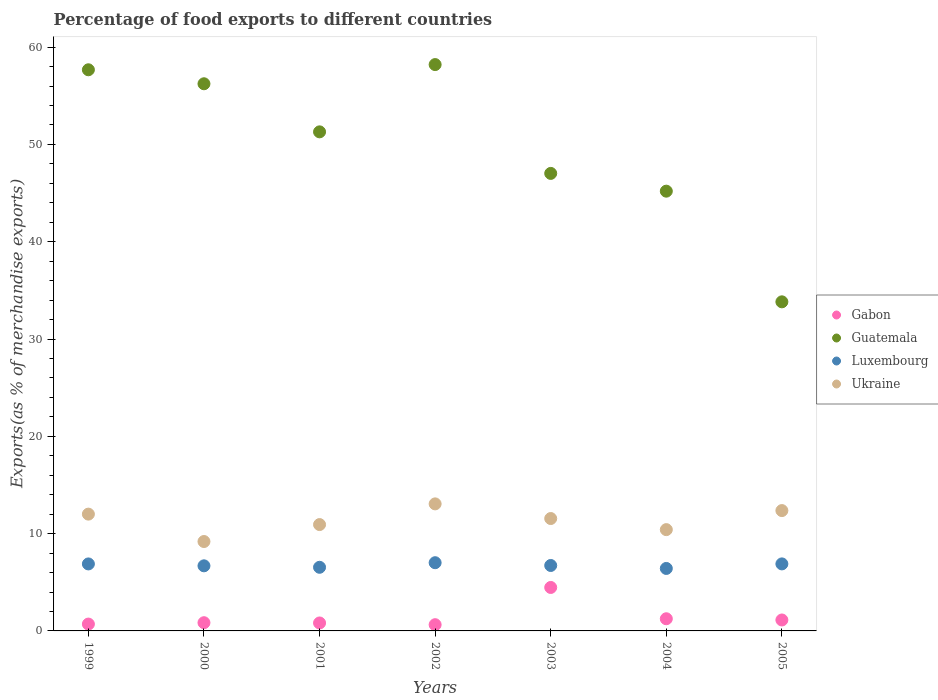How many different coloured dotlines are there?
Ensure brevity in your answer.  4. What is the percentage of exports to different countries in Ukraine in 2005?
Make the answer very short. 12.37. Across all years, what is the maximum percentage of exports to different countries in Luxembourg?
Provide a succinct answer. 7.01. Across all years, what is the minimum percentage of exports to different countries in Ukraine?
Provide a succinct answer. 9.19. What is the total percentage of exports to different countries in Guatemala in the graph?
Provide a succinct answer. 349.43. What is the difference between the percentage of exports to different countries in Guatemala in 1999 and that in 2004?
Ensure brevity in your answer.  12.48. What is the difference between the percentage of exports to different countries in Luxembourg in 2000 and the percentage of exports to different countries in Ukraine in 2001?
Your answer should be very brief. -4.24. What is the average percentage of exports to different countries in Gabon per year?
Your response must be concise. 1.41. In the year 2003, what is the difference between the percentage of exports to different countries in Gabon and percentage of exports to different countries in Luxembourg?
Make the answer very short. -2.26. In how many years, is the percentage of exports to different countries in Luxembourg greater than 4 %?
Your response must be concise. 7. What is the ratio of the percentage of exports to different countries in Ukraine in 1999 to that in 2005?
Your response must be concise. 0.97. Is the percentage of exports to different countries in Guatemala in 2004 less than that in 2005?
Offer a terse response. No. Is the difference between the percentage of exports to different countries in Gabon in 2000 and 2004 greater than the difference between the percentage of exports to different countries in Luxembourg in 2000 and 2004?
Give a very brief answer. No. What is the difference between the highest and the second highest percentage of exports to different countries in Gabon?
Provide a short and direct response. 3.22. What is the difference between the highest and the lowest percentage of exports to different countries in Luxembourg?
Keep it short and to the point. 0.59. Is it the case that in every year, the sum of the percentage of exports to different countries in Gabon and percentage of exports to different countries in Guatemala  is greater than the sum of percentage of exports to different countries in Ukraine and percentage of exports to different countries in Luxembourg?
Your answer should be very brief. Yes. Is the percentage of exports to different countries in Gabon strictly greater than the percentage of exports to different countries in Guatemala over the years?
Your answer should be very brief. No. What is the difference between two consecutive major ticks on the Y-axis?
Your answer should be very brief. 10. Are the values on the major ticks of Y-axis written in scientific E-notation?
Offer a terse response. No. Does the graph contain any zero values?
Keep it short and to the point. No. Where does the legend appear in the graph?
Offer a terse response. Center right. How many legend labels are there?
Offer a terse response. 4. What is the title of the graph?
Offer a terse response. Percentage of food exports to different countries. Does "Korea (Republic)" appear as one of the legend labels in the graph?
Offer a very short reply. No. What is the label or title of the X-axis?
Your answer should be very brief. Years. What is the label or title of the Y-axis?
Your answer should be very brief. Exports(as % of merchandise exports). What is the Exports(as % of merchandise exports) of Gabon in 1999?
Offer a terse response. 0.7. What is the Exports(as % of merchandise exports) in Guatemala in 1999?
Give a very brief answer. 57.67. What is the Exports(as % of merchandise exports) in Luxembourg in 1999?
Ensure brevity in your answer.  6.88. What is the Exports(as % of merchandise exports) of Ukraine in 1999?
Give a very brief answer. 12. What is the Exports(as % of merchandise exports) of Gabon in 2000?
Keep it short and to the point. 0.84. What is the Exports(as % of merchandise exports) of Guatemala in 2000?
Your answer should be very brief. 56.23. What is the Exports(as % of merchandise exports) in Luxembourg in 2000?
Your answer should be compact. 6.69. What is the Exports(as % of merchandise exports) of Ukraine in 2000?
Offer a terse response. 9.19. What is the Exports(as % of merchandise exports) of Gabon in 2001?
Your answer should be compact. 0.82. What is the Exports(as % of merchandise exports) in Guatemala in 2001?
Your response must be concise. 51.29. What is the Exports(as % of merchandise exports) of Luxembourg in 2001?
Provide a short and direct response. 6.54. What is the Exports(as % of merchandise exports) of Ukraine in 2001?
Make the answer very short. 10.93. What is the Exports(as % of merchandise exports) in Gabon in 2002?
Make the answer very short. 0.64. What is the Exports(as % of merchandise exports) in Guatemala in 2002?
Your answer should be very brief. 58.2. What is the Exports(as % of merchandise exports) in Luxembourg in 2002?
Offer a terse response. 7.01. What is the Exports(as % of merchandise exports) in Ukraine in 2002?
Your answer should be compact. 13.06. What is the Exports(as % of merchandise exports) in Gabon in 2003?
Give a very brief answer. 4.47. What is the Exports(as % of merchandise exports) of Guatemala in 2003?
Keep it short and to the point. 47.02. What is the Exports(as % of merchandise exports) in Luxembourg in 2003?
Provide a succinct answer. 6.72. What is the Exports(as % of merchandise exports) in Ukraine in 2003?
Your answer should be very brief. 11.55. What is the Exports(as % of merchandise exports) of Gabon in 2004?
Offer a very short reply. 1.25. What is the Exports(as % of merchandise exports) in Guatemala in 2004?
Ensure brevity in your answer.  45.19. What is the Exports(as % of merchandise exports) in Luxembourg in 2004?
Offer a terse response. 6.42. What is the Exports(as % of merchandise exports) of Ukraine in 2004?
Your response must be concise. 10.41. What is the Exports(as % of merchandise exports) of Gabon in 2005?
Provide a short and direct response. 1.12. What is the Exports(as % of merchandise exports) of Guatemala in 2005?
Give a very brief answer. 33.82. What is the Exports(as % of merchandise exports) of Luxembourg in 2005?
Give a very brief answer. 6.89. What is the Exports(as % of merchandise exports) in Ukraine in 2005?
Provide a short and direct response. 12.37. Across all years, what is the maximum Exports(as % of merchandise exports) of Gabon?
Your answer should be compact. 4.47. Across all years, what is the maximum Exports(as % of merchandise exports) of Guatemala?
Offer a very short reply. 58.2. Across all years, what is the maximum Exports(as % of merchandise exports) of Luxembourg?
Offer a terse response. 7.01. Across all years, what is the maximum Exports(as % of merchandise exports) in Ukraine?
Give a very brief answer. 13.06. Across all years, what is the minimum Exports(as % of merchandise exports) of Gabon?
Make the answer very short. 0.64. Across all years, what is the minimum Exports(as % of merchandise exports) of Guatemala?
Your response must be concise. 33.82. Across all years, what is the minimum Exports(as % of merchandise exports) in Luxembourg?
Keep it short and to the point. 6.42. Across all years, what is the minimum Exports(as % of merchandise exports) in Ukraine?
Make the answer very short. 9.19. What is the total Exports(as % of merchandise exports) of Gabon in the graph?
Your response must be concise. 9.85. What is the total Exports(as % of merchandise exports) in Guatemala in the graph?
Your response must be concise. 349.43. What is the total Exports(as % of merchandise exports) in Luxembourg in the graph?
Provide a succinct answer. 47.16. What is the total Exports(as % of merchandise exports) of Ukraine in the graph?
Provide a short and direct response. 79.5. What is the difference between the Exports(as % of merchandise exports) in Gabon in 1999 and that in 2000?
Give a very brief answer. -0.14. What is the difference between the Exports(as % of merchandise exports) of Guatemala in 1999 and that in 2000?
Give a very brief answer. 1.44. What is the difference between the Exports(as % of merchandise exports) of Luxembourg in 1999 and that in 2000?
Your response must be concise. 0.2. What is the difference between the Exports(as % of merchandise exports) in Ukraine in 1999 and that in 2000?
Offer a very short reply. 2.82. What is the difference between the Exports(as % of merchandise exports) in Gabon in 1999 and that in 2001?
Your answer should be compact. -0.11. What is the difference between the Exports(as % of merchandise exports) in Guatemala in 1999 and that in 2001?
Ensure brevity in your answer.  6.38. What is the difference between the Exports(as % of merchandise exports) in Luxembourg in 1999 and that in 2001?
Keep it short and to the point. 0.35. What is the difference between the Exports(as % of merchandise exports) of Ukraine in 1999 and that in 2001?
Your response must be concise. 1.07. What is the difference between the Exports(as % of merchandise exports) of Gabon in 1999 and that in 2002?
Make the answer very short. 0.06. What is the difference between the Exports(as % of merchandise exports) in Guatemala in 1999 and that in 2002?
Your response must be concise. -0.53. What is the difference between the Exports(as % of merchandise exports) of Luxembourg in 1999 and that in 2002?
Your response must be concise. -0.12. What is the difference between the Exports(as % of merchandise exports) of Ukraine in 1999 and that in 2002?
Your answer should be very brief. -1.05. What is the difference between the Exports(as % of merchandise exports) in Gabon in 1999 and that in 2003?
Provide a succinct answer. -3.76. What is the difference between the Exports(as % of merchandise exports) of Guatemala in 1999 and that in 2003?
Provide a short and direct response. 10.65. What is the difference between the Exports(as % of merchandise exports) in Luxembourg in 1999 and that in 2003?
Ensure brevity in your answer.  0.16. What is the difference between the Exports(as % of merchandise exports) in Ukraine in 1999 and that in 2003?
Your response must be concise. 0.45. What is the difference between the Exports(as % of merchandise exports) in Gabon in 1999 and that in 2004?
Your response must be concise. -0.55. What is the difference between the Exports(as % of merchandise exports) of Guatemala in 1999 and that in 2004?
Your response must be concise. 12.48. What is the difference between the Exports(as % of merchandise exports) of Luxembourg in 1999 and that in 2004?
Give a very brief answer. 0.46. What is the difference between the Exports(as % of merchandise exports) in Ukraine in 1999 and that in 2004?
Make the answer very short. 1.59. What is the difference between the Exports(as % of merchandise exports) of Gabon in 1999 and that in 2005?
Offer a very short reply. -0.42. What is the difference between the Exports(as % of merchandise exports) in Guatemala in 1999 and that in 2005?
Make the answer very short. 23.85. What is the difference between the Exports(as % of merchandise exports) of Luxembourg in 1999 and that in 2005?
Provide a succinct answer. -0. What is the difference between the Exports(as % of merchandise exports) of Ukraine in 1999 and that in 2005?
Your answer should be compact. -0.36. What is the difference between the Exports(as % of merchandise exports) of Gabon in 2000 and that in 2001?
Provide a short and direct response. 0.03. What is the difference between the Exports(as % of merchandise exports) in Guatemala in 2000 and that in 2001?
Make the answer very short. 4.94. What is the difference between the Exports(as % of merchandise exports) in Ukraine in 2000 and that in 2001?
Make the answer very short. -1.74. What is the difference between the Exports(as % of merchandise exports) in Gabon in 2000 and that in 2002?
Provide a succinct answer. 0.2. What is the difference between the Exports(as % of merchandise exports) of Guatemala in 2000 and that in 2002?
Ensure brevity in your answer.  -1.97. What is the difference between the Exports(as % of merchandise exports) of Luxembourg in 2000 and that in 2002?
Give a very brief answer. -0.32. What is the difference between the Exports(as % of merchandise exports) of Ukraine in 2000 and that in 2002?
Give a very brief answer. -3.87. What is the difference between the Exports(as % of merchandise exports) of Gabon in 2000 and that in 2003?
Keep it short and to the point. -3.62. What is the difference between the Exports(as % of merchandise exports) of Guatemala in 2000 and that in 2003?
Your answer should be very brief. 9.21. What is the difference between the Exports(as % of merchandise exports) of Luxembourg in 2000 and that in 2003?
Keep it short and to the point. -0.04. What is the difference between the Exports(as % of merchandise exports) of Ukraine in 2000 and that in 2003?
Your response must be concise. -2.36. What is the difference between the Exports(as % of merchandise exports) in Gabon in 2000 and that in 2004?
Your answer should be very brief. -0.41. What is the difference between the Exports(as % of merchandise exports) in Guatemala in 2000 and that in 2004?
Ensure brevity in your answer.  11.04. What is the difference between the Exports(as % of merchandise exports) of Luxembourg in 2000 and that in 2004?
Give a very brief answer. 0.27. What is the difference between the Exports(as % of merchandise exports) in Ukraine in 2000 and that in 2004?
Your response must be concise. -1.22. What is the difference between the Exports(as % of merchandise exports) in Gabon in 2000 and that in 2005?
Offer a very short reply. -0.28. What is the difference between the Exports(as % of merchandise exports) of Guatemala in 2000 and that in 2005?
Give a very brief answer. 22.41. What is the difference between the Exports(as % of merchandise exports) in Luxembourg in 2000 and that in 2005?
Your answer should be compact. -0.2. What is the difference between the Exports(as % of merchandise exports) in Ukraine in 2000 and that in 2005?
Your answer should be very brief. -3.18. What is the difference between the Exports(as % of merchandise exports) in Gabon in 2001 and that in 2002?
Your response must be concise. 0.18. What is the difference between the Exports(as % of merchandise exports) of Guatemala in 2001 and that in 2002?
Provide a short and direct response. -6.91. What is the difference between the Exports(as % of merchandise exports) of Luxembourg in 2001 and that in 2002?
Provide a short and direct response. -0.47. What is the difference between the Exports(as % of merchandise exports) of Ukraine in 2001 and that in 2002?
Ensure brevity in your answer.  -2.13. What is the difference between the Exports(as % of merchandise exports) of Gabon in 2001 and that in 2003?
Provide a short and direct response. -3.65. What is the difference between the Exports(as % of merchandise exports) of Guatemala in 2001 and that in 2003?
Offer a terse response. 4.27. What is the difference between the Exports(as % of merchandise exports) in Luxembourg in 2001 and that in 2003?
Offer a very short reply. -0.19. What is the difference between the Exports(as % of merchandise exports) in Ukraine in 2001 and that in 2003?
Provide a succinct answer. -0.62. What is the difference between the Exports(as % of merchandise exports) of Gabon in 2001 and that in 2004?
Your answer should be compact. -0.43. What is the difference between the Exports(as % of merchandise exports) in Guatemala in 2001 and that in 2004?
Provide a short and direct response. 6.1. What is the difference between the Exports(as % of merchandise exports) of Luxembourg in 2001 and that in 2004?
Offer a very short reply. 0.12. What is the difference between the Exports(as % of merchandise exports) in Ukraine in 2001 and that in 2004?
Provide a short and direct response. 0.52. What is the difference between the Exports(as % of merchandise exports) of Gabon in 2001 and that in 2005?
Make the answer very short. -0.31. What is the difference between the Exports(as % of merchandise exports) in Guatemala in 2001 and that in 2005?
Your answer should be compact. 17.47. What is the difference between the Exports(as % of merchandise exports) in Luxembourg in 2001 and that in 2005?
Offer a very short reply. -0.35. What is the difference between the Exports(as % of merchandise exports) of Ukraine in 2001 and that in 2005?
Make the answer very short. -1.44. What is the difference between the Exports(as % of merchandise exports) of Gabon in 2002 and that in 2003?
Offer a very short reply. -3.83. What is the difference between the Exports(as % of merchandise exports) in Guatemala in 2002 and that in 2003?
Your answer should be very brief. 11.18. What is the difference between the Exports(as % of merchandise exports) of Luxembourg in 2002 and that in 2003?
Keep it short and to the point. 0.28. What is the difference between the Exports(as % of merchandise exports) of Ukraine in 2002 and that in 2003?
Offer a very short reply. 1.51. What is the difference between the Exports(as % of merchandise exports) of Gabon in 2002 and that in 2004?
Your response must be concise. -0.61. What is the difference between the Exports(as % of merchandise exports) in Guatemala in 2002 and that in 2004?
Make the answer very short. 13.01. What is the difference between the Exports(as % of merchandise exports) of Luxembourg in 2002 and that in 2004?
Provide a short and direct response. 0.59. What is the difference between the Exports(as % of merchandise exports) of Ukraine in 2002 and that in 2004?
Provide a succinct answer. 2.65. What is the difference between the Exports(as % of merchandise exports) in Gabon in 2002 and that in 2005?
Provide a short and direct response. -0.48. What is the difference between the Exports(as % of merchandise exports) of Guatemala in 2002 and that in 2005?
Give a very brief answer. 24.38. What is the difference between the Exports(as % of merchandise exports) of Luxembourg in 2002 and that in 2005?
Offer a very short reply. 0.12. What is the difference between the Exports(as % of merchandise exports) of Ukraine in 2002 and that in 2005?
Your response must be concise. 0.69. What is the difference between the Exports(as % of merchandise exports) of Gabon in 2003 and that in 2004?
Provide a short and direct response. 3.22. What is the difference between the Exports(as % of merchandise exports) of Guatemala in 2003 and that in 2004?
Your answer should be very brief. 1.83. What is the difference between the Exports(as % of merchandise exports) in Luxembourg in 2003 and that in 2004?
Your response must be concise. 0.3. What is the difference between the Exports(as % of merchandise exports) of Ukraine in 2003 and that in 2004?
Provide a succinct answer. 1.14. What is the difference between the Exports(as % of merchandise exports) of Gabon in 2003 and that in 2005?
Provide a short and direct response. 3.34. What is the difference between the Exports(as % of merchandise exports) of Guatemala in 2003 and that in 2005?
Offer a terse response. 13.2. What is the difference between the Exports(as % of merchandise exports) in Luxembourg in 2003 and that in 2005?
Offer a very short reply. -0.16. What is the difference between the Exports(as % of merchandise exports) in Ukraine in 2003 and that in 2005?
Your answer should be compact. -0.82. What is the difference between the Exports(as % of merchandise exports) of Gabon in 2004 and that in 2005?
Offer a very short reply. 0.13. What is the difference between the Exports(as % of merchandise exports) of Guatemala in 2004 and that in 2005?
Offer a very short reply. 11.37. What is the difference between the Exports(as % of merchandise exports) of Luxembourg in 2004 and that in 2005?
Your response must be concise. -0.47. What is the difference between the Exports(as % of merchandise exports) in Ukraine in 2004 and that in 2005?
Make the answer very short. -1.96. What is the difference between the Exports(as % of merchandise exports) of Gabon in 1999 and the Exports(as % of merchandise exports) of Guatemala in 2000?
Your response must be concise. -55.53. What is the difference between the Exports(as % of merchandise exports) of Gabon in 1999 and the Exports(as % of merchandise exports) of Luxembourg in 2000?
Give a very brief answer. -5.99. What is the difference between the Exports(as % of merchandise exports) in Gabon in 1999 and the Exports(as % of merchandise exports) in Ukraine in 2000?
Offer a very short reply. -8.48. What is the difference between the Exports(as % of merchandise exports) of Guatemala in 1999 and the Exports(as % of merchandise exports) of Luxembourg in 2000?
Keep it short and to the point. 50.98. What is the difference between the Exports(as % of merchandise exports) of Guatemala in 1999 and the Exports(as % of merchandise exports) of Ukraine in 2000?
Your answer should be compact. 48.48. What is the difference between the Exports(as % of merchandise exports) of Luxembourg in 1999 and the Exports(as % of merchandise exports) of Ukraine in 2000?
Keep it short and to the point. -2.3. What is the difference between the Exports(as % of merchandise exports) of Gabon in 1999 and the Exports(as % of merchandise exports) of Guatemala in 2001?
Ensure brevity in your answer.  -50.59. What is the difference between the Exports(as % of merchandise exports) of Gabon in 1999 and the Exports(as % of merchandise exports) of Luxembourg in 2001?
Offer a terse response. -5.84. What is the difference between the Exports(as % of merchandise exports) of Gabon in 1999 and the Exports(as % of merchandise exports) of Ukraine in 2001?
Make the answer very short. -10.23. What is the difference between the Exports(as % of merchandise exports) of Guatemala in 1999 and the Exports(as % of merchandise exports) of Luxembourg in 2001?
Ensure brevity in your answer.  51.13. What is the difference between the Exports(as % of merchandise exports) of Guatemala in 1999 and the Exports(as % of merchandise exports) of Ukraine in 2001?
Ensure brevity in your answer.  46.74. What is the difference between the Exports(as % of merchandise exports) of Luxembourg in 1999 and the Exports(as % of merchandise exports) of Ukraine in 2001?
Keep it short and to the point. -4.04. What is the difference between the Exports(as % of merchandise exports) in Gabon in 1999 and the Exports(as % of merchandise exports) in Guatemala in 2002?
Your answer should be very brief. -57.5. What is the difference between the Exports(as % of merchandise exports) of Gabon in 1999 and the Exports(as % of merchandise exports) of Luxembourg in 2002?
Provide a succinct answer. -6.31. What is the difference between the Exports(as % of merchandise exports) in Gabon in 1999 and the Exports(as % of merchandise exports) in Ukraine in 2002?
Provide a short and direct response. -12.35. What is the difference between the Exports(as % of merchandise exports) in Guatemala in 1999 and the Exports(as % of merchandise exports) in Luxembourg in 2002?
Provide a succinct answer. 50.66. What is the difference between the Exports(as % of merchandise exports) in Guatemala in 1999 and the Exports(as % of merchandise exports) in Ukraine in 2002?
Your response must be concise. 44.61. What is the difference between the Exports(as % of merchandise exports) in Luxembourg in 1999 and the Exports(as % of merchandise exports) in Ukraine in 2002?
Your answer should be very brief. -6.17. What is the difference between the Exports(as % of merchandise exports) of Gabon in 1999 and the Exports(as % of merchandise exports) of Guatemala in 2003?
Ensure brevity in your answer.  -46.32. What is the difference between the Exports(as % of merchandise exports) of Gabon in 1999 and the Exports(as % of merchandise exports) of Luxembourg in 2003?
Give a very brief answer. -6.02. What is the difference between the Exports(as % of merchandise exports) of Gabon in 1999 and the Exports(as % of merchandise exports) of Ukraine in 2003?
Provide a succinct answer. -10.85. What is the difference between the Exports(as % of merchandise exports) of Guatemala in 1999 and the Exports(as % of merchandise exports) of Luxembourg in 2003?
Make the answer very short. 50.95. What is the difference between the Exports(as % of merchandise exports) in Guatemala in 1999 and the Exports(as % of merchandise exports) in Ukraine in 2003?
Keep it short and to the point. 46.12. What is the difference between the Exports(as % of merchandise exports) of Luxembourg in 1999 and the Exports(as % of merchandise exports) of Ukraine in 2003?
Ensure brevity in your answer.  -4.67. What is the difference between the Exports(as % of merchandise exports) of Gabon in 1999 and the Exports(as % of merchandise exports) of Guatemala in 2004?
Offer a very short reply. -44.49. What is the difference between the Exports(as % of merchandise exports) in Gabon in 1999 and the Exports(as % of merchandise exports) in Luxembourg in 2004?
Provide a succinct answer. -5.72. What is the difference between the Exports(as % of merchandise exports) in Gabon in 1999 and the Exports(as % of merchandise exports) in Ukraine in 2004?
Your answer should be very brief. -9.71. What is the difference between the Exports(as % of merchandise exports) of Guatemala in 1999 and the Exports(as % of merchandise exports) of Luxembourg in 2004?
Your answer should be compact. 51.25. What is the difference between the Exports(as % of merchandise exports) of Guatemala in 1999 and the Exports(as % of merchandise exports) of Ukraine in 2004?
Offer a terse response. 47.26. What is the difference between the Exports(as % of merchandise exports) of Luxembourg in 1999 and the Exports(as % of merchandise exports) of Ukraine in 2004?
Offer a terse response. -3.52. What is the difference between the Exports(as % of merchandise exports) in Gabon in 1999 and the Exports(as % of merchandise exports) in Guatemala in 2005?
Make the answer very short. -33.12. What is the difference between the Exports(as % of merchandise exports) in Gabon in 1999 and the Exports(as % of merchandise exports) in Luxembourg in 2005?
Your answer should be very brief. -6.18. What is the difference between the Exports(as % of merchandise exports) of Gabon in 1999 and the Exports(as % of merchandise exports) of Ukraine in 2005?
Your answer should be compact. -11.66. What is the difference between the Exports(as % of merchandise exports) in Guatemala in 1999 and the Exports(as % of merchandise exports) in Luxembourg in 2005?
Offer a terse response. 50.78. What is the difference between the Exports(as % of merchandise exports) of Guatemala in 1999 and the Exports(as % of merchandise exports) of Ukraine in 2005?
Make the answer very short. 45.3. What is the difference between the Exports(as % of merchandise exports) of Luxembourg in 1999 and the Exports(as % of merchandise exports) of Ukraine in 2005?
Ensure brevity in your answer.  -5.48. What is the difference between the Exports(as % of merchandise exports) of Gabon in 2000 and the Exports(as % of merchandise exports) of Guatemala in 2001?
Ensure brevity in your answer.  -50.45. What is the difference between the Exports(as % of merchandise exports) of Gabon in 2000 and the Exports(as % of merchandise exports) of Luxembourg in 2001?
Provide a succinct answer. -5.7. What is the difference between the Exports(as % of merchandise exports) of Gabon in 2000 and the Exports(as % of merchandise exports) of Ukraine in 2001?
Keep it short and to the point. -10.09. What is the difference between the Exports(as % of merchandise exports) of Guatemala in 2000 and the Exports(as % of merchandise exports) of Luxembourg in 2001?
Ensure brevity in your answer.  49.69. What is the difference between the Exports(as % of merchandise exports) in Guatemala in 2000 and the Exports(as % of merchandise exports) in Ukraine in 2001?
Provide a succinct answer. 45.3. What is the difference between the Exports(as % of merchandise exports) of Luxembourg in 2000 and the Exports(as % of merchandise exports) of Ukraine in 2001?
Provide a succinct answer. -4.24. What is the difference between the Exports(as % of merchandise exports) of Gabon in 2000 and the Exports(as % of merchandise exports) of Guatemala in 2002?
Ensure brevity in your answer.  -57.36. What is the difference between the Exports(as % of merchandise exports) of Gabon in 2000 and the Exports(as % of merchandise exports) of Luxembourg in 2002?
Provide a succinct answer. -6.17. What is the difference between the Exports(as % of merchandise exports) of Gabon in 2000 and the Exports(as % of merchandise exports) of Ukraine in 2002?
Your answer should be very brief. -12.21. What is the difference between the Exports(as % of merchandise exports) in Guatemala in 2000 and the Exports(as % of merchandise exports) in Luxembourg in 2002?
Give a very brief answer. 49.22. What is the difference between the Exports(as % of merchandise exports) of Guatemala in 2000 and the Exports(as % of merchandise exports) of Ukraine in 2002?
Your answer should be very brief. 43.18. What is the difference between the Exports(as % of merchandise exports) in Luxembourg in 2000 and the Exports(as % of merchandise exports) in Ukraine in 2002?
Offer a very short reply. -6.37. What is the difference between the Exports(as % of merchandise exports) in Gabon in 2000 and the Exports(as % of merchandise exports) in Guatemala in 2003?
Offer a very short reply. -46.18. What is the difference between the Exports(as % of merchandise exports) of Gabon in 2000 and the Exports(as % of merchandise exports) of Luxembourg in 2003?
Your response must be concise. -5.88. What is the difference between the Exports(as % of merchandise exports) in Gabon in 2000 and the Exports(as % of merchandise exports) in Ukraine in 2003?
Your response must be concise. -10.71. What is the difference between the Exports(as % of merchandise exports) in Guatemala in 2000 and the Exports(as % of merchandise exports) in Luxembourg in 2003?
Your response must be concise. 49.51. What is the difference between the Exports(as % of merchandise exports) in Guatemala in 2000 and the Exports(as % of merchandise exports) in Ukraine in 2003?
Give a very brief answer. 44.68. What is the difference between the Exports(as % of merchandise exports) in Luxembourg in 2000 and the Exports(as % of merchandise exports) in Ukraine in 2003?
Keep it short and to the point. -4.86. What is the difference between the Exports(as % of merchandise exports) of Gabon in 2000 and the Exports(as % of merchandise exports) of Guatemala in 2004?
Your answer should be very brief. -44.35. What is the difference between the Exports(as % of merchandise exports) in Gabon in 2000 and the Exports(as % of merchandise exports) in Luxembourg in 2004?
Give a very brief answer. -5.58. What is the difference between the Exports(as % of merchandise exports) in Gabon in 2000 and the Exports(as % of merchandise exports) in Ukraine in 2004?
Provide a short and direct response. -9.57. What is the difference between the Exports(as % of merchandise exports) in Guatemala in 2000 and the Exports(as % of merchandise exports) in Luxembourg in 2004?
Provide a short and direct response. 49.81. What is the difference between the Exports(as % of merchandise exports) in Guatemala in 2000 and the Exports(as % of merchandise exports) in Ukraine in 2004?
Your answer should be compact. 45.82. What is the difference between the Exports(as % of merchandise exports) in Luxembourg in 2000 and the Exports(as % of merchandise exports) in Ukraine in 2004?
Your answer should be very brief. -3.72. What is the difference between the Exports(as % of merchandise exports) of Gabon in 2000 and the Exports(as % of merchandise exports) of Guatemala in 2005?
Offer a terse response. -32.98. What is the difference between the Exports(as % of merchandise exports) in Gabon in 2000 and the Exports(as % of merchandise exports) in Luxembourg in 2005?
Give a very brief answer. -6.04. What is the difference between the Exports(as % of merchandise exports) of Gabon in 2000 and the Exports(as % of merchandise exports) of Ukraine in 2005?
Give a very brief answer. -11.52. What is the difference between the Exports(as % of merchandise exports) in Guatemala in 2000 and the Exports(as % of merchandise exports) in Luxembourg in 2005?
Ensure brevity in your answer.  49.34. What is the difference between the Exports(as % of merchandise exports) of Guatemala in 2000 and the Exports(as % of merchandise exports) of Ukraine in 2005?
Your answer should be compact. 43.87. What is the difference between the Exports(as % of merchandise exports) in Luxembourg in 2000 and the Exports(as % of merchandise exports) in Ukraine in 2005?
Offer a terse response. -5.68. What is the difference between the Exports(as % of merchandise exports) in Gabon in 2001 and the Exports(as % of merchandise exports) in Guatemala in 2002?
Provide a short and direct response. -57.39. What is the difference between the Exports(as % of merchandise exports) in Gabon in 2001 and the Exports(as % of merchandise exports) in Luxembourg in 2002?
Offer a terse response. -6.19. What is the difference between the Exports(as % of merchandise exports) of Gabon in 2001 and the Exports(as % of merchandise exports) of Ukraine in 2002?
Offer a very short reply. -12.24. What is the difference between the Exports(as % of merchandise exports) of Guatemala in 2001 and the Exports(as % of merchandise exports) of Luxembourg in 2002?
Your response must be concise. 44.28. What is the difference between the Exports(as % of merchandise exports) of Guatemala in 2001 and the Exports(as % of merchandise exports) of Ukraine in 2002?
Your answer should be compact. 38.23. What is the difference between the Exports(as % of merchandise exports) in Luxembourg in 2001 and the Exports(as % of merchandise exports) in Ukraine in 2002?
Keep it short and to the point. -6.52. What is the difference between the Exports(as % of merchandise exports) of Gabon in 2001 and the Exports(as % of merchandise exports) of Guatemala in 2003?
Provide a succinct answer. -46.2. What is the difference between the Exports(as % of merchandise exports) of Gabon in 2001 and the Exports(as % of merchandise exports) of Luxembourg in 2003?
Make the answer very short. -5.91. What is the difference between the Exports(as % of merchandise exports) of Gabon in 2001 and the Exports(as % of merchandise exports) of Ukraine in 2003?
Provide a short and direct response. -10.73. What is the difference between the Exports(as % of merchandise exports) in Guatemala in 2001 and the Exports(as % of merchandise exports) in Luxembourg in 2003?
Give a very brief answer. 44.57. What is the difference between the Exports(as % of merchandise exports) in Guatemala in 2001 and the Exports(as % of merchandise exports) in Ukraine in 2003?
Offer a very short reply. 39.74. What is the difference between the Exports(as % of merchandise exports) in Luxembourg in 2001 and the Exports(as % of merchandise exports) in Ukraine in 2003?
Provide a succinct answer. -5.01. What is the difference between the Exports(as % of merchandise exports) in Gabon in 2001 and the Exports(as % of merchandise exports) in Guatemala in 2004?
Ensure brevity in your answer.  -44.38. What is the difference between the Exports(as % of merchandise exports) in Gabon in 2001 and the Exports(as % of merchandise exports) in Luxembourg in 2004?
Give a very brief answer. -5.6. What is the difference between the Exports(as % of merchandise exports) of Gabon in 2001 and the Exports(as % of merchandise exports) of Ukraine in 2004?
Provide a short and direct response. -9.59. What is the difference between the Exports(as % of merchandise exports) of Guatemala in 2001 and the Exports(as % of merchandise exports) of Luxembourg in 2004?
Give a very brief answer. 44.87. What is the difference between the Exports(as % of merchandise exports) of Guatemala in 2001 and the Exports(as % of merchandise exports) of Ukraine in 2004?
Offer a very short reply. 40.88. What is the difference between the Exports(as % of merchandise exports) in Luxembourg in 2001 and the Exports(as % of merchandise exports) in Ukraine in 2004?
Ensure brevity in your answer.  -3.87. What is the difference between the Exports(as % of merchandise exports) of Gabon in 2001 and the Exports(as % of merchandise exports) of Guatemala in 2005?
Provide a short and direct response. -33. What is the difference between the Exports(as % of merchandise exports) of Gabon in 2001 and the Exports(as % of merchandise exports) of Luxembourg in 2005?
Your answer should be compact. -6.07. What is the difference between the Exports(as % of merchandise exports) in Gabon in 2001 and the Exports(as % of merchandise exports) in Ukraine in 2005?
Offer a terse response. -11.55. What is the difference between the Exports(as % of merchandise exports) in Guatemala in 2001 and the Exports(as % of merchandise exports) in Luxembourg in 2005?
Your response must be concise. 44.4. What is the difference between the Exports(as % of merchandise exports) of Guatemala in 2001 and the Exports(as % of merchandise exports) of Ukraine in 2005?
Offer a terse response. 38.92. What is the difference between the Exports(as % of merchandise exports) of Luxembourg in 2001 and the Exports(as % of merchandise exports) of Ukraine in 2005?
Provide a succinct answer. -5.83. What is the difference between the Exports(as % of merchandise exports) in Gabon in 2002 and the Exports(as % of merchandise exports) in Guatemala in 2003?
Offer a very short reply. -46.38. What is the difference between the Exports(as % of merchandise exports) of Gabon in 2002 and the Exports(as % of merchandise exports) of Luxembourg in 2003?
Provide a short and direct response. -6.08. What is the difference between the Exports(as % of merchandise exports) in Gabon in 2002 and the Exports(as % of merchandise exports) in Ukraine in 2003?
Keep it short and to the point. -10.91. What is the difference between the Exports(as % of merchandise exports) of Guatemala in 2002 and the Exports(as % of merchandise exports) of Luxembourg in 2003?
Offer a very short reply. 51.48. What is the difference between the Exports(as % of merchandise exports) of Guatemala in 2002 and the Exports(as % of merchandise exports) of Ukraine in 2003?
Make the answer very short. 46.65. What is the difference between the Exports(as % of merchandise exports) of Luxembourg in 2002 and the Exports(as % of merchandise exports) of Ukraine in 2003?
Your answer should be compact. -4.54. What is the difference between the Exports(as % of merchandise exports) in Gabon in 2002 and the Exports(as % of merchandise exports) in Guatemala in 2004?
Provide a succinct answer. -44.55. What is the difference between the Exports(as % of merchandise exports) of Gabon in 2002 and the Exports(as % of merchandise exports) of Luxembourg in 2004?
Your answer should be very brief. -5.78. What is the difference between the Exports(as % of merchandise exports) of Gabon in 2002 and the Exports(as % of merchandise exports) of Ukraine in 2004?
Ensure brevity in your answer.  -9.77. What is the difference between the Exports(as % of merchandise exports) of Guatemala in 2002 and the Exports(as % of merchandise exports) of Luxembourg in 2004?
Your response must be concise. 51.78. What is the difference between the Exports(as % of merchandise exports) in Guatemala in 2002 and the Exports(as % of merchandise exports) in Ukraine in 2004?
Provide a short and direct response. 47.79. What is the difference between the Exports(as % of merchandise exports) in Luxembourg in 2002 and the Exports(as % of merchandise exports) in Ukraine in 2004?
Offer a very short reply. -3.4. What is the difference between the Exports(as % of merchandise exports) in Gabon in 2002 and the Exports(as % of merchandise exports) in Guatemala in 2005?
Provide a short and direct response. -33.18. What is the difference between the Exports(as % of merchandise exports) in Gabon in 2002 and the Exports(as % of merchandise exports) in Luxembourg in 2005?
Provide a succinct answer. -6.25. What is the difference between the Exports(as % of merchandise exports) of Gabon in 2002 and the Exports(as % of merchandise exports) of Ukraine in 2005?
Keep it short and to the point. -11.73. What is the difference between the Exports(as % of merchandise exports) in Guatemala in 2002 and the Exports(as % of merchandise exports) in Luxembourg in 2005?
Offer a terse response. 51.32. What is the difference between the Exports(as % of merchandise exports) in Guatemala in 2002 and the Exports(as % of merchandise exports) in Ukraine in 2005?
Ensure brevity in your answer.  45.84. What is the difference between the Exports(as % of merchandise exports) of Luxembourg in 2002 and the Exports(as % of merchandise exports) of Ukraine in 2005?
Your response must be concise. -5.36. What is the difference between the Exports(as % of merchandise exports) of Gabon in 2003 and the Exports(as % of merchandise exports) of Guatemala in 2004?
Ensure brevity in your answer.  -40.73. What is the difference between the Exports(as % of merchandise exports) of Gabon in 2003 and the Exports(as % of merchandise exports) of Luxembourg in 2004?
Offer a terse response. -1.95. What is the difference between the Exports(as % of merchandise exports) of Gabon in 2003 and the Exports(as % of merchandise exports) of Ukraine in 2004?
Your answer should be compact. -5.94. What is the difference between the Exports(as % of merchandise exports) in Guatemala in 2003 and the Exports(as % of merchandise exports) in Luxembourg in 2004?
Your response must be concise. 40.6. What is the difference between the Exports(as % of merchandise exports) in Guatemala in 2003 and the Exports(as % of merchandise exports) in Ukraine in 2004?
Give a very brief answer. 36.61. What is the difference between the Exports(as % of merchandise exports) in Luxembourg in 2003 and the Exports(as % of merchandise exports) in Ukraine in 2004?
Offer a terse response. -3.68. What is the difference between the Exports(as % of merchandise exports) of Gabon in 2003 and the Exports(as % of merchandise exports) of Guatemala in 2005?
Give a very brief answer. -29.36. What is the difference between the Exports(as % of merchandise exports) of Gabon in 2003 and the Exports(as % of merchandise exports) of Luxembourg in 2005?
Offer a very short reply. -2.42. What is the difference between the Exports(as % of merchandise exports) of Gabon in 2003 and the Exports(as % of merchandise exports) of Ukraine in 2005?
Ensure brevity in your answer.  -7.9. What is the difference between the Exports(as % of merchandise exports) of Guatemala in 2003 and the Exports(as % of merchandise exports) of Luxembourg in 2005?
Offer a terse response. 40.13. What is the difference between the Exports(as % of merchandise exports) in Guatemala in 2003 and the Exports(as % of merchandise exports) in Ukraine in 2005?
Offer a terse response. 34.65. What is the difference between the Exports(as % of merchandise exports) in Luxembourg in 2003 and the Exports(as % of merchandise exports) in Ukraine in 2005?
Offer a terse response. -5.64. What is the difference between the Exports(as % of merchandise exports) in Gabon in 2004 and the Exports(as % of merchandise exports) in Guatemala in 2005?
Offer a terse response. -32.57. What is the difference between the Exports(as % of merchandise exports) of Gabon in 2004 and the Exports(as % of merchandise exports) of Luxembourg in 2005?
Keep it short and to the point. -5.64. What is the difference between the Exports(as % of merchandise exports) of Gabon in 2004 and the Exports(as % of merchandise exports) of Ukraine in 2005?
Offer a terse response. -11.12. What is the difference between the Exports(as % of merchandise exports) in Guatemala in 2004 and the Exports(as % of merchandise exports) in Luxembourg in 2005?
Make the answer very short. 38.31. What is the difference between the Exports(as % of merchandise exports) in Guatemala in 2004 and the Exports(as % of merchandise exports) in Ukraine in 2005?
Keep it short and to the point. 32.83. What is the difference between the Exports(as % of merchandise exports) of Luxembourg in 2004 and the Exports(as % of merchandise exports) of Ukraine in 2005?
Give a very brief answer. -5.95. What is the average Exports(as % of merchandise exports) of Gabon per year?
Provide a succinct answer. 1.41. What is the average Exports(as % of merchandise exports) in Guatemala per year?
Provide a short and direct response. 49.92. What is the average Exports(as % of merchandise exports) in Luxembourg per year?
Offer a terse response. 6.74. What is the average Exports(as % of merchandise exports) in Ukraine per year?
Offer a very short reply. 11.36. In the year 1999, what is the difference between the Exports(as % of merchandise exports) of Gabon and Exports(as % of merchandise exports) of Guatemala?
Make the answer very short. -56.97. In the year 1999, what is the difference between the Exports(as % of merchandise exports) in Gabon and Exports(as % of merchandise exports) in Luxembourg?
Make the answer very short. -6.18. In the year 1999, what is the difference between the Exports(as % of merchandise exports) of Gabon and Exports(as % of merchandise exports) of Ukraine?
Keep it short and to the point. -11.3. In the year 1999, what is the difference between the Exports(as % of merchandise exports) of Guatemala and Exports(as % of merchandise exports) of Luxembourg?
Give a very brief answer. 50.78. In the year 1999, what is the difference between the Exports(as % of merchandise exports) in Guatemala and Exports(as % of merchandise exports) in Ukraine?
Offer a very short reply. 45.67. In the year 1999, what is the difference between the Exports(as % of merchandise exports) in Luxembourg and Exports(as % of merchandise exports) in Ukraine?
Provide a succinct answer. -5.12. In the year 2000, what is the difference between the Exports(as % of merchandise exports) of Gabon and Exports(as % of merchandise exports) of Guatemala?
Offer a terse response. -55.39. In the year 2000, what is the difference between the Exports(as % of merchandise exports) of Gabon and Exports(as % of merchandise exports) of Luxembourg?
Your answer should be very brief. -5.85. In the year 2000, what is the difference between the Exports(as % of merchandise exports) of Gabon and Exports(as % of merchandise exports) of Ukraine?
Make the answer very short. -8.34. In the year 2000, what is the difference between the Exports(as % of merchandise exports) of Guatemala and Exports(as % of merchandise exports) of Luxembourg?
Keep it short and to the point. 49.54. In the year 2000, what is the difference between the Exports(as % of merchandise exports) of Guatemala and Exports(as % of merchandise exports) of Ukraine?
Provide a short and direct response. 47.04. In the year 2000, what is the difference between the Exports(as % of merchandise exports) in Luxembourg and Exports(as % of merchandise exports) in Ukraine?
Give a very brief answer. -2.5. In the year 2001, what is the difference between the Exports(as % of merchandise exports) in Gabon and Exports(as % of merchandise exports) in Guatemala?
Keep it short and to the point. -50.47. In the year 2001, what is the difference between the Exports(as % of merchandise exports) of Gabon and Exports(as % of merchandise exports) of Luxembourg?
Your answer should be compact. -5.72. In the year 2001, what is the difference between the Exports(as % of merchandise exports) in Gabon and Exports(as % of merchandise exports) in Ukraine?
Keep it short and to the point. -10.11. In the year 2001, what is the difference between the Exports(as % of merchandise exports) in Guatemala and Exports(as % of merchandise exports) in Luxembourg?
Make the answer very short. 44.75. In the year 2001, what is the difference between the Exports(as % of merchandise exports) of Guatemala and Exports(as % of merchandise exports) of Ukraine?
Keep it short and to the point. 40.36. In the year 2001, what is the difference between the Exports(as % of merchandise exports) in Luxembourg and Exports(as % of merchandise exports) in Ukraine?
Ensure brevity in your answer.  -4.39. In the year 2002, what is the difference between the Exports(as % of merchandise exports) in Gabon and Exports(as % of merchandise exports) in Guatemala?
Make the answer very short. -57.56. In the year 2002, what is the difference between the Exports(as % of merchandise exports) in Gabon and Exports(as % of merchandise exports) in Luxembourg?
Provide a short and direct response. -6.37. In the year 2002, what is the difference between the Exports(as % of merchandise exports) of Gabon and Exports(as % of merchandise exports) of Ukraine?
Your answer should be very brief. -12.42. In the year 2002, what is the difference between the Exports(as % of merchandise exports) in Guatemala and Exports(as % of merchandise exports) in Luxembourg?
Your response must be concise. 51.19. In the year 2002, what is the difference between the Exports(as % of merchandise exports) of Guatemala and Exports(as % of merchandise exports) of Ukraine?
Make the answer very short. 45.15. In the year 2002, what is the difference between the Exports(as % of merchandise exports) of Luxembourg and Exports(as % of merchandise exports) of Ukraine?
Your answer should be compact. -6.05. In the year 2003, what is the difference between the Exports(as % of merchandise exports) of Gabon and Exports(as % of merchandise exports) of Guatemala?
Give a very brief answer. -42.55. In the year 2003, what is the difference between the Exports(as % of merchandise exports) in Gabon and Exports(as % of merchandise exports) in Luxembourg?
Provide a succinct answer. -2.26. In the year 2003, what is the difference between the Exports(as % of merchandise exports) of Gabon and Exports(as % of merchandise exports) of Ukraine?
Keep it short and to the point. -7.08. In the year 2003, what is the difference between the Exports(as % of merchandise exports) of Guatemala and Exports(as % of merchandise exports) of Luxembourg?
Offer a terse response. 40.3. In the year 2003, what is the difference between the Exports(as % of merchandise exports) in Guatemala and Exports(as % of merchandise exports) in Ukraine?
Make the answer very short. 35.47. In the year 2003, what is the difference between the Exports(as % of merchandise exports) of Luxembourg and Exports(as % of merchandise exports) of Ukraine?
Make the answer very short. -4.83. In the year 2004, what is the difference between the Exports(as % of merchandise exports) of Gabon and Exports(as % of merchandise exports) of Guatemala?
Provide a succinct answer. -43.94. In the year 2004, what is the difference between the Exports(as % of merchandise exports) of Gabon and Exports(as % of merchandise exports) of Luxembourg?
Keep it short and to the point. -5.17. In the year 2004, what is the difference between the Exports(as % of merchandise exports) in Gabon and Exports(as % of merchandise exports) in Ukraine?
Make the answer very short. -9.16. In the year 2004, what is the difference between the Exports(as % of merchandise exports) of Guatemala and Exports(as % of merchandise exports) of Luxembourg?
Offer a terse response. 38.77. In the year 2004, what is the difference between the Exports(as % of merchandise exports) in Guatemala and Exports(as % of merchandise exports) in Ukraine?
Offer a terse response. 34.79. In the year 2004, what is the difference between the Exports(as % of merchandise exports) in Luxembourg and Exports(as % of merchandise exports) in Ukraine?
Keep it short and to the point. -3.99. In the year 2005, what is the difference between the Exports(as % of merchandise exports) of Gabon and Exports(as % of merchandise exports) of Guatemala?
Give a very brief answer. -32.7. In the year 2005, what is the difference between the Exports(as % of merchandise exports) in Gabon and Exports(as % of merchandise exports) in Luxembourg?
Make the answer very short. -5.76. In the year 2005, what is the difference between the Exports(as % of merchandise exports) in Gabon and Exports(as % of merchandise exports) in Ukraine?
Your answer should be compact. -11.24. In the year 2005, what is the difference between the Exports(as % of merchandise exports) of Guatemala and Exports(as % of merchandise exports) of Luxembourg?
Offer a very short reply. 26.93. In the year 2005, what is the difference between the Exports(as % of merchandise exports) in Guatemala and Exports(as % of merchandise exports) in Ukraine?
Offer a very short reply. 21.45. In the year 2005, what is the difference between the Exports(as % of merchandise exports) in Luxembourg and Exports(as % of merchandise exports) in Ukraine?
Provide a short and direct response. -5.48. What is the ratio of the Exports(as % of merchandise exports) of Gabon in 1999 to that in 2000?
Provide a short and direct response. 0.83. What is the ratio of the Exports(as % of merchandise exports) of Guatemala in 1999 to that in 2000?
Keep it short and to the point. 1.03. What is the ratio of the Exports(as % of merchandise exports) of Luxembourg in 1999 to that in 2000?
Your answer should be compact. 1.03. What is the ratio of the Exports(as % of merchandise exports) in Ukraine in 1999 to that in 2000?
Your answer should be compact. 1.31. What is the ratio of the Exports(as % of merchandise exports) of Gabon in 1999 to that in 2001?
Provide a succinct answer. 0.86. What is the ratio of the Exports(as % of merchandise exports) of Guatemala in 1999 to that in 2001?
Offer a very short reply. 1.12. What is the ratio of the Exports(as % of merchandise exports) in Luxembourg in 1999 to that in 2001?
Offer a very short reply. 1.05. What is the ratio of the Exports(as % of merchandise exports) in Ukraine in 1999 to that in 2001?
Offer a terse response. 1.1. What is the ratio of the Exports(as % of merchandise exports) in Gabon in 1999 to that in 2002?
Make the answer very short. 1.1. What is the ratio of the Exports(as % of merchandise exports) in Guatemala in 1999 to that in 2002?
Your answer should be compact. 0.99. What is the ratio of the Exports(as % of merchandise exports) in Luxembourg in 1999 to that in 2002?
Offer a terse response. 0.98. What is the ratio of the Exports(as % of merchandise exports) of Ukraine in 1999 to that in 2002?
Make the answer very short. 0.92. What is the ratio of the Exports(as % of merchandise exports) in Gabon in 1999 to that in 2003?
Your response must be concise. 0.16. What is the ratio of the Exports(as % of merchandise exports) in Guatemala in 1999 to that in 2003?
Give a very brief answer. 1.23. What is the ratio of the Exports(as % of merchandise exports) in Luxembourg in 1999 to that in 2003?
Provide a succinct answer. 1.02. What is the ratio of the Exports(as % of merchandise exports) in Ukraine in 1999 to that in 2003?
Offer a very short reply. 1.04. What is the ratio of the Exports(as % of merchandise exports) of Gabon in 1999 to that in 2004?
Provide a succinct answer. 0.56. What is the ratio of the Exports(as % of merchandise exports) in Guatemala in 1999 to that in 2004?
Offer a very short reply. 1.28. What is the ratio of the Exports(as % of merchandise exports) in Luxembourg in 1999 to that in 2004?
Your answer should be very brief. 1.07. What is the ratio of the Exports(as % of merchandise exports) in Ukraine in 1999 to that in 2004?
Give a very brief answer. 1.15. What is the ratio of the Exports(as % of merchandise exports) in Gabon in 1999 to that in 2005?
Provide a short and direct response. 0.63. What is the ratio of the Exports(as % of merchandise exports) in Guatemala in 1999 to that in 2005?
Make the answer very short. 1.71. What is the ratio of the Exports(as % of merchandise exports) in Luxembourg in 1999 to that in 2005?
Your response must be concise. 1. What is the ratio of the Exports(as % of merchandise exports) of Ukraine in 1999 to that in 2005?
Your answer should be very brief. 0.97. What is the ratio of the Exports(as % of merchandise exports) in Gabon in 2000 to that in 2001?
Offer a terse response. 1.03. What is the ratio of the Exports(as % of merchandise exports) in Guatemala in 2000 to that in 2001?
Provide a succinct answer. 1.1. What is the ratio of the Exports(as % of merchandise exports) of Luxembourg in 2000 to that in 2001?
Offer a very short reply. 1.02. What is the ratio of the Exports(as % of merchandise exports) in Ukraine in 2000 to that in 2001?
Keep it short and to the point. 0.84. What is the ratio of the Exports(as % of merchandise exports) in Gabon in 2000 to that in 2002?
Keep it short and to the point. 1.32. What is the ratio of the Exports(as % of merchandise exports) of Guatemala in 2000 to that in 2002?
Your answer should be compact. 0.97. What is the ratio of the Exports(as % of merchandise exports) in Luxembourg in 2000 to that in 2002?
Provide a short and direct response. 0.95. What is the ratio of the Exports(as % of merchandise exports) of Ukraine in 2000 to that in 2002?
Your answer should be compact. 0.7. What is the ratio of the Exports(as % of merchandise exports) in Gabon in 2000 to that in 2003?
Provide a succinct answer. 0.19. What is the ratio of the Exports(as % of merchandise exports) in Guatemala in 2000 to that in 2003?
Keep it short and to the point. 1.2. What is the ratio of the Exports(as % of merchandise exports) in Luxembourg in 2000 to that in 2003?
Your answer should be very brief. 0.99. What is the ratio of the Exports(as % of merchandise exports) in Ukraine in 2000 to that in 2003?
Make the answer very short. 0.8. What is the ratio of the Exports(as % of merchandise exports) of Gabon in 2000 to that in 2004?
Your response must be concise. 0.68. What is the ratio of the Exports(as % of merchandise exports) of Guatemala in 2000 to that in 2004?
Keep it short and to the point. 1.24. What is the ratio of the Exports(as % of merchandise exports) of Luxembourg in 2000 to that in 2004?
Your response must be concise. 1.04. What is the ratio of the Exports(as % of merchandise exports) of Ukraine in 2000 to that in 2004?
Your answer should be very brief. 0.88. What is the ratio of the Exports(as % of merchandise exports) in Gabon in 2000 to that in 2005?
Offer a terse response. 0.75. What is the ratio of the Exports(as % of merchandise exports) of Guatemala in 2000 to that in 2005?
Keep it short and to the point. 1.66. What is the ratio of the Exports(as % of merchandise exports) of Luxembourg in 2000 to that in 2005?
Your answer should be very brief. 0.97. What is the ratio of the Exports(as % of merchandise exports) in Ukraine in 2000 to that in 2005?
Your answer should be very brief. 0.74. What is the ratio of the Exports(as % of merchandise exports) in Gabon in 2001 to that in 2002?
Give a very brief answer. 1.28. What is the ratio of the Exports(as % of merchandise exports) of Guatemala in 2001 to that in 2002?
Your answer should be very brief. 0.88. What is the ratio of the Exports(as % of merchandise exports) of Luxembourg in 2001 to that in 2002?
Make the answer very short. 0.93. What is the ratio of the Exports(as % of merchandise exports) of Ukraine in 2001 to that in 2002?
Keep it short and to the point. 0.84. What is the ratio of the Exports(as % of merchandise exports) of Gabon in 2001 to that in 2003?
Offer a very short reply. 0.18. What is the ratio of the Exports(as % of merchandise exports) of Guatemala in 2001 to that in 2003?
Your response must be concise. 1.09. What is the ratio of the Exports(as % of merchandise exports) of Luxembourg in 2001 to that in 2003?
Provide a short and direct response. 0.97. What is the ratio of the Exports(as % of merchandise exports) in Ukraine in 2001 to that in 2003?
Keep it short and to the point. 0.95. What is the ratio of the Exports(as % of merchandise exports) in Gabon in 2001 to that in 2004?
Your answer should be compact. 0.65. What is the ratio of the Exports(as % of merchandise exports) in Guatemala in 2001 to that in 2004?
Your answer should be compact. 1.13. What is the ratio of the Exports(as % of merchandise exports) in Luxembourg in 2001 to that in 2004?
Offer a terse response. 1.02. What is the ratio of the Exports(as % of merchandise exports) of Gabon in 2001 to that in 2005?
Make the answer very short. 0.73. What is the ratio of the Exports(as % of merchandise exports) of Guatemala in 2001 to that in 2005?
Give a very brief answer. 1.52. What is the ratio of the Exports(as % of merchandise exports) of Luxembourg in 2001 to that in 2005?
Your response must be concise. 0.95. What is the ratio of the Exports(as % of merchandise exports) in Ukraine in 2001 to that in 2005?
Make the answer very short. 0.88. What is the ratio of the Exports(as % of merchandise exports) in Gabon in 2002 to that in 2003?
Ensure brevity in your answer.  0.14. What is the ratio of the Exports(as % of merchandise exports) in Guatemala in 2002 to that in 2003?
Keep it short and to the point. 1.24. What is the ratio of the Exports(as % of merchandise exports) in Luxembourg in 2002 to that in 2003?
Keep it short and to the point. 1.04. What is the ratio of the Exports(as % of merchandise exports) in Ukraine in 2002 to that in 2003?
Your answer should be compact. 1.13. What is the ratio of the Exports(as % of merchandise exports) of Gabon in 2002 to that in 2004?
Make the answer very short. 0.51. What is the ratio of the Exports(as % of merchandise exports) of Guatemala in 2002 to that in 2004?
Keep it short and to the point. 1.29. What is the ratio of the Exports(as % of merchandise exports) in Luxembourg in 2002 to that in 2004?
Provide a short and direct response. 1.09. What is the ratio of the Exports(as % of merchandise exports) of Ukraine in 2002 to that in 2004?
Your answer should be very brief. 1.25. What is the ratio of the Exports(as % of merchandise exports) in Gabon in 2002 to that in 2005?
Give a very brief answer. 0.57. What is the ratio of the Exports(as % of merchandise exports) in Guatemala in 2002 to that in 2005?
Provide a short and direct response. 1.72. What is the ratio of the Exports(as % of merchandise exports) in Luxembourg in 2002 to that in 2005?
Your answer should be very brief. 1.02. What is the ratio of the Exports(as % of merchandise exports) in Ukraine in 2002 to that in 2005?
Keep it short and to the point. 1.06. What is the ratio of the Exports(as % of merchandise exports) of Gabon in 2003 to that in 2004?
Your answer should be compact. 3.57. What is the ratio of the Exports(as % of merchandise exports) of Guatemala in 2003 to that in 2004?
Make the answer very short. 1.04. What is the ratio of the Exports(as % of merchandise exports) of Luxembourg in 2003 to that in 2004?
Offer a very short reply. 1.05. What is the ratio of the Exports(as % of merchandise exports) of Ukraine in 2003 to that in 2004?
Provide a short and direct response. 1.11. What is the ratio of the Exports(as % of merchandise exports) in Gabon in 2003 to that in 2005?
Your answer should be very brief. 3.97. What is the ratio of the Exports(as % of merchandise exports) of Guatemala in 2003 to that in 2005?
Give a very brief answer. 1.39. What is the ratio of the Exports(as % of merchandise exports) in Luxembourg in 2003 to that in 2005?
Offer a very short reply. 0.98. What is the ratio of the Exports(as % of merchandise exports) of Ukraine in 2003 to that in 2005?
Make the answer very short. 0.93. What is the ratio of the Exports(as % of merchandise exports) in Gabon in 2004 to that in 2005?
Keep it short and to the point. 1.11. What is the ratio of the Exports(as % of merchandise exports) in Guatemala in 2004 to that in 2005?
Make the answer very short. 1.34. What is the ratio of the Exports(as % of merchandise exports) in Luxembourg in 2004 to that in 2005?
Your answer should be compact. 0.93. What is the ratio of the Exports(as % of merchandise exports) in Ukraine in 2004 to that in 2005?
Provide a short and direct response. 0.84. What is the difference between the highest and the second highest Exports(as % of merchandise exports) in Gabon?
Make the answer very short. 3.22. What is the difference between the highest and the second highest Exports(as % of merchandise exports) in Guatemala?
Your answer should be compact. 0.53. What is the difference between the highest and the second highest Exports(as % of merchandise exports) of Luxembourg?
Ensure brevity in your answer.  0.12. What is the difference between the highest and the second highest Exports(as % of merchandise exports) of Ukraine?
Ensure brevity in your answer.  0.69. What is the difference between the highest and the lowest Exports(as % of merchandise exports) in Gabon?
Make the answer very short. 3.83. What is the difference between the highest and the lowest Exports(as % of merchandise exports) in Guatemala?
Give a very brief answer. 24.38. What is the difference between the highest and the lowest Exports(as % of merchandise exports) of Luxembourg?
Keep it short and to the point. 0.59. What is the difference between the highest and the lowest Exports(as % of merchandise exports) in Ukraine?
Provide a short and direct response. 3.87. 